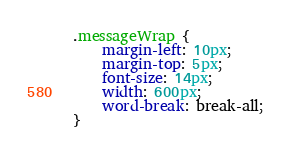Convert code to text. <code><loc_0><loc_0><loc_500><loc_500><_CSS_>.messageWrap {
    margin-left: 10px;
    margin-top: 5px;
    font-size: 14px;
    width: 600px;
    word-break: break-all;
}</code> 